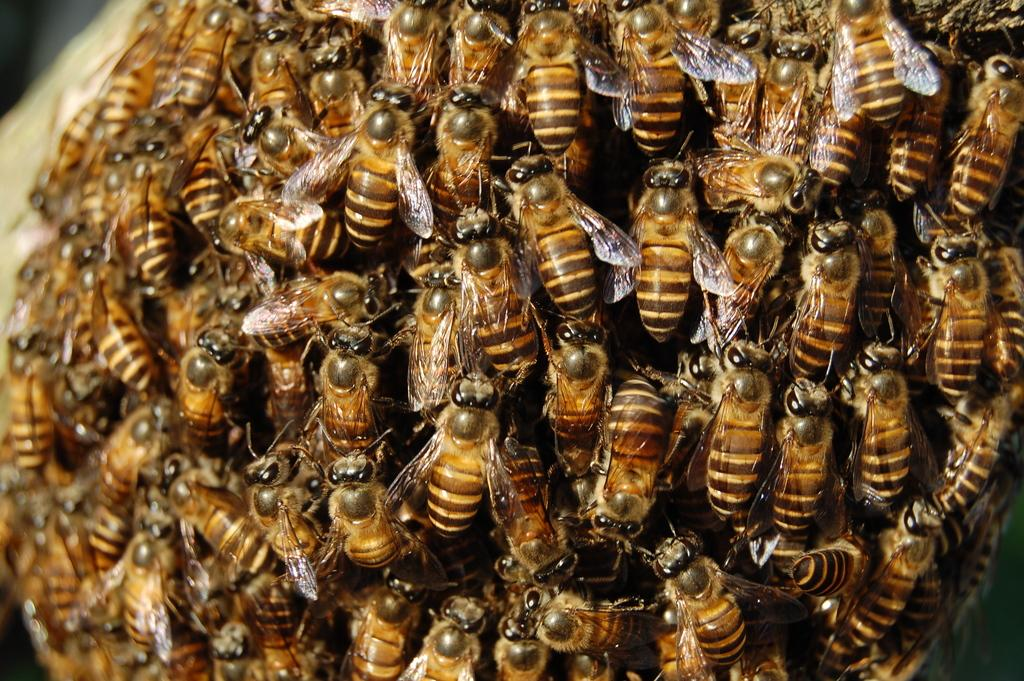What type of living organisms can be seen in the image? There is a group of insects in the image. What type of transport is being used by the insects in the image? There is no transport present in the image, as it features a group of insects. Can you tell me if any other insects are trying to join the group in the image? There is no indication in the image that any other insects are trying to join the group. What type of ornament is visible on the insects in the image? There is no ornament present on the insects in the image. 